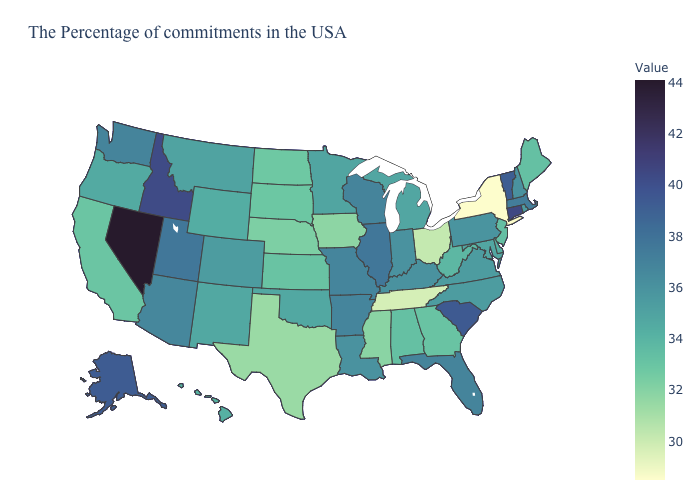Does Louisiana have the lowest value in the USA?
Give a very brief answer. No. Does the map have missing data?
Be succinct. No. Does Minnesota have a higher value than Ohio?
Quick response, please. Yes. Which states hav the highest value in the South?
Quick response, please. South Carolina. Among the states that border Kansas , does Oklahoma have the lowest value?
Answer briefly. No. 